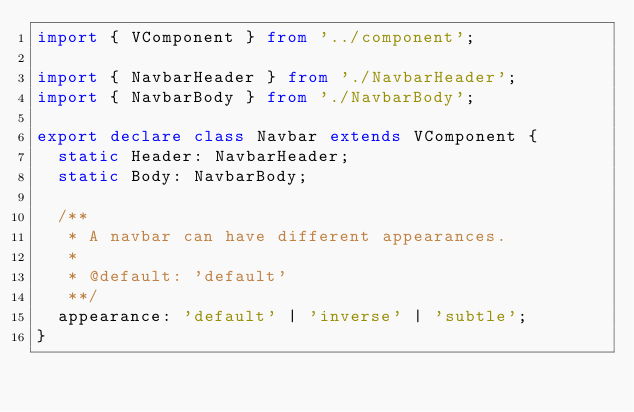<code> <loc_0><loc_0><loc_500><loc_500><_TypeScript_>import { VComponent } from '../component';

import { NavbarHeader } from './NavbarHeader';
import { NavbarBody } from './NavbarBody';

export declare class Navbar extends VComponent {
  static Header: NavbarHeader;
  static Body: NavbarBody;

  /**
   * A navbar can have different appearances.
   *
   * @default: 'default'
   **/
  appearance: 'default' | 'inverse' | 'subtle';
}
</code> 